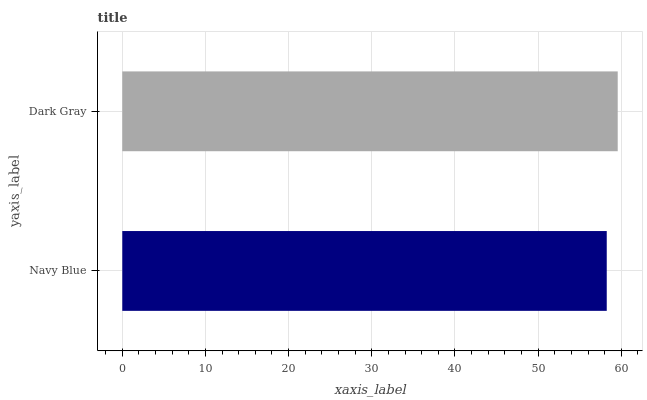Is Navy Blue the minimum?
Answer yes or no. Yes. Is Dark Gray the maximum?
Answer yes or no. Yes. Is Dark Gray the minimum?
Answer yes or no. No. Is Dark Gray greater than Navy Blue?
Answer yes or no. Yes. Is Navy Blue less than Dark Gray?
Answer yes or no. Yes. Is Navy Blue greater than Dark Gray?
Answer yes or no. No. Is Dark Gray less than Navy Blue?
Answer yes or no. No. Is Dark Gray the high median?
Answer yes or no. Yes. Is Navy Blue the low median?
Answer yes or no. Yes. Is Navy Blue the high median?
Answer yes or no. No. Is Dark Gray the low median?
Answer yes or no. No. 